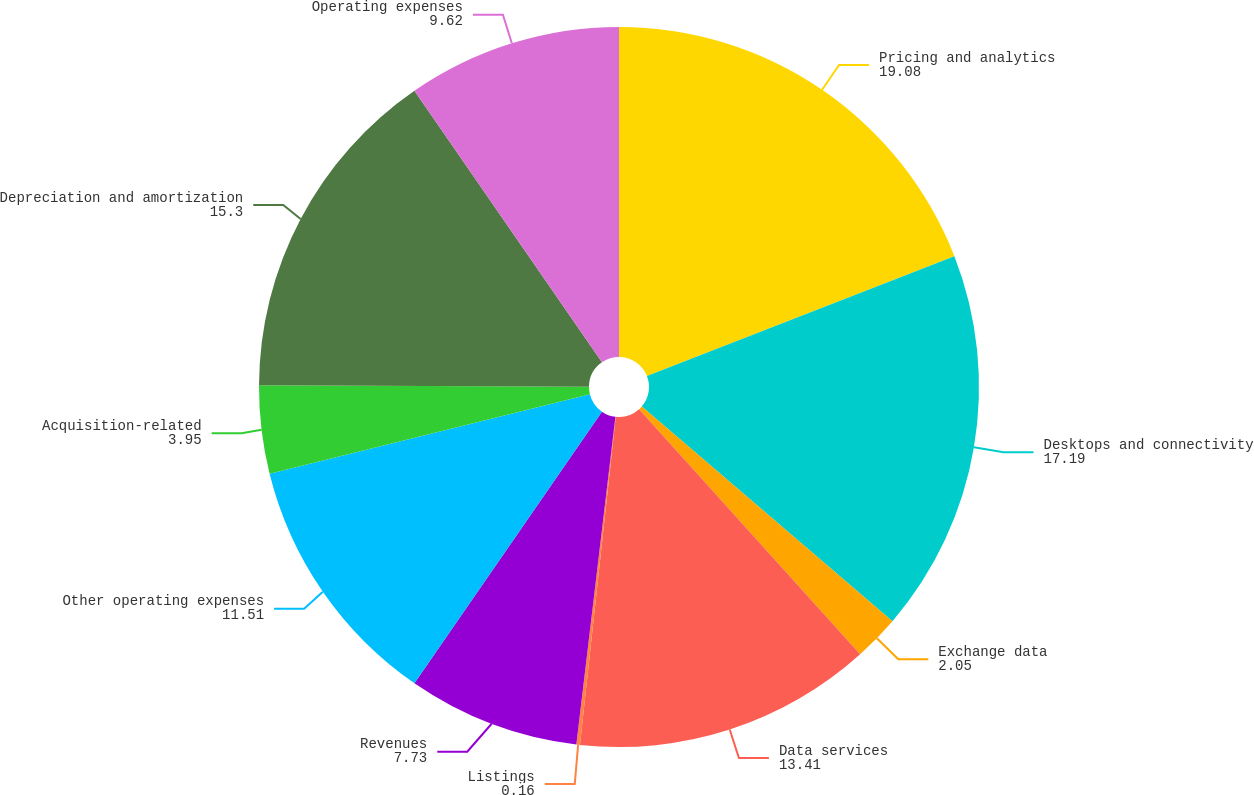Convert chart to OTSL. <chart><loc_0><loc_0><loc_500><loc_500><pie_chart><fcel>Pricing and analytics<fcel>Desktops and connectivity<fcel>Exchange data<fcel>Data services<fcel>Listings<fcel>Revenues<fcel>Other operating expenses<fcel>Acquisition-related<fcel>Depreciation and amortization<fcel>Operating expenses<nl><fcel>19.08%<fcel>17.19%<fcel>2.05%<fcel>13.41%<fcel>0.16%<fcel>7.73%<fcel>11.51%<fcel>3.95%<fcel>15.3%<fcel>9.62%<nl></chart> 